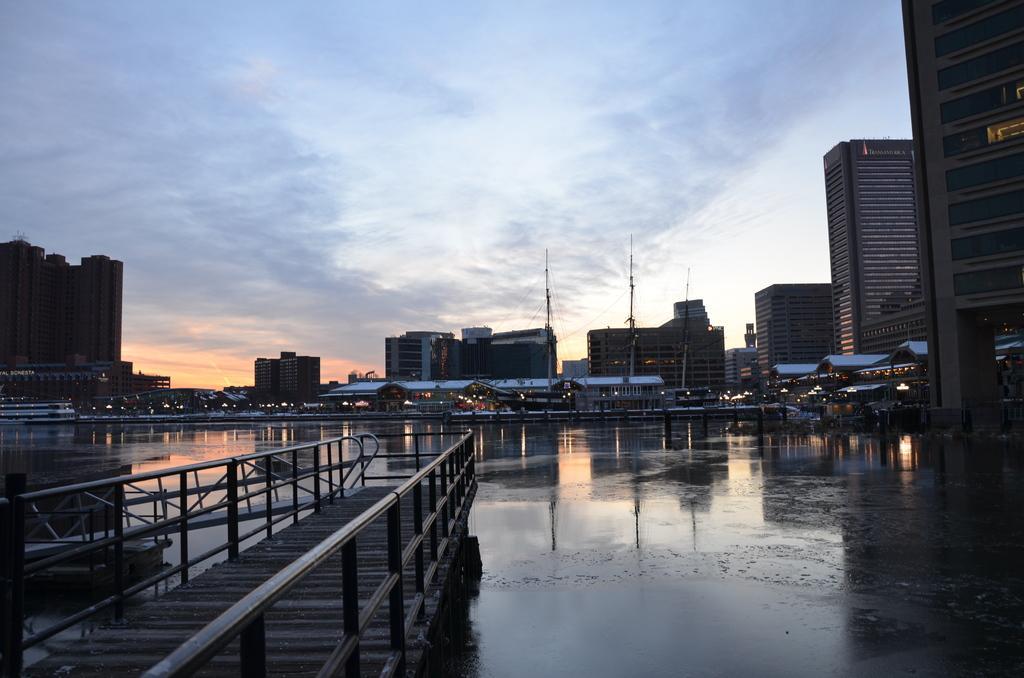In one or two sentences, can you explain what this image depicts? This image is taken during the evening time. In this image we can see the buildings, houses, lights and also the poles with the wires. We can also see the bridge, boat and also the water. In the background we can see the sky with some clouds. 